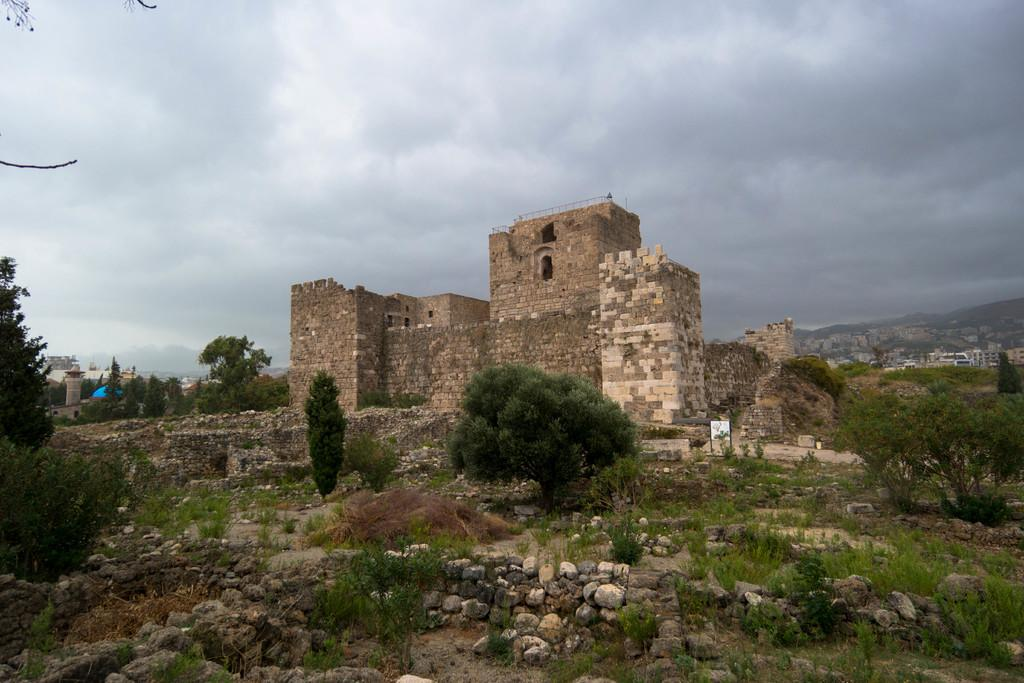What type of structure is in the image? There is a building in the image. What is located in front of the building? There are trees, grass, and stones in front of the building. Can you describe the background of the image? There are buildings visible in the background, and the sky is visible with clouds present. What type of straw is being used to stir the cup in the image? There is no cup or straw present in the image; it features a building with trees, grass, and stones in front of it. 